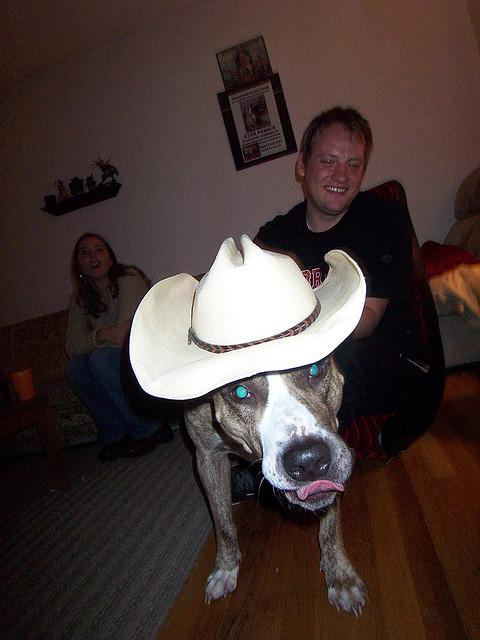Who put the hat on the dog? man 